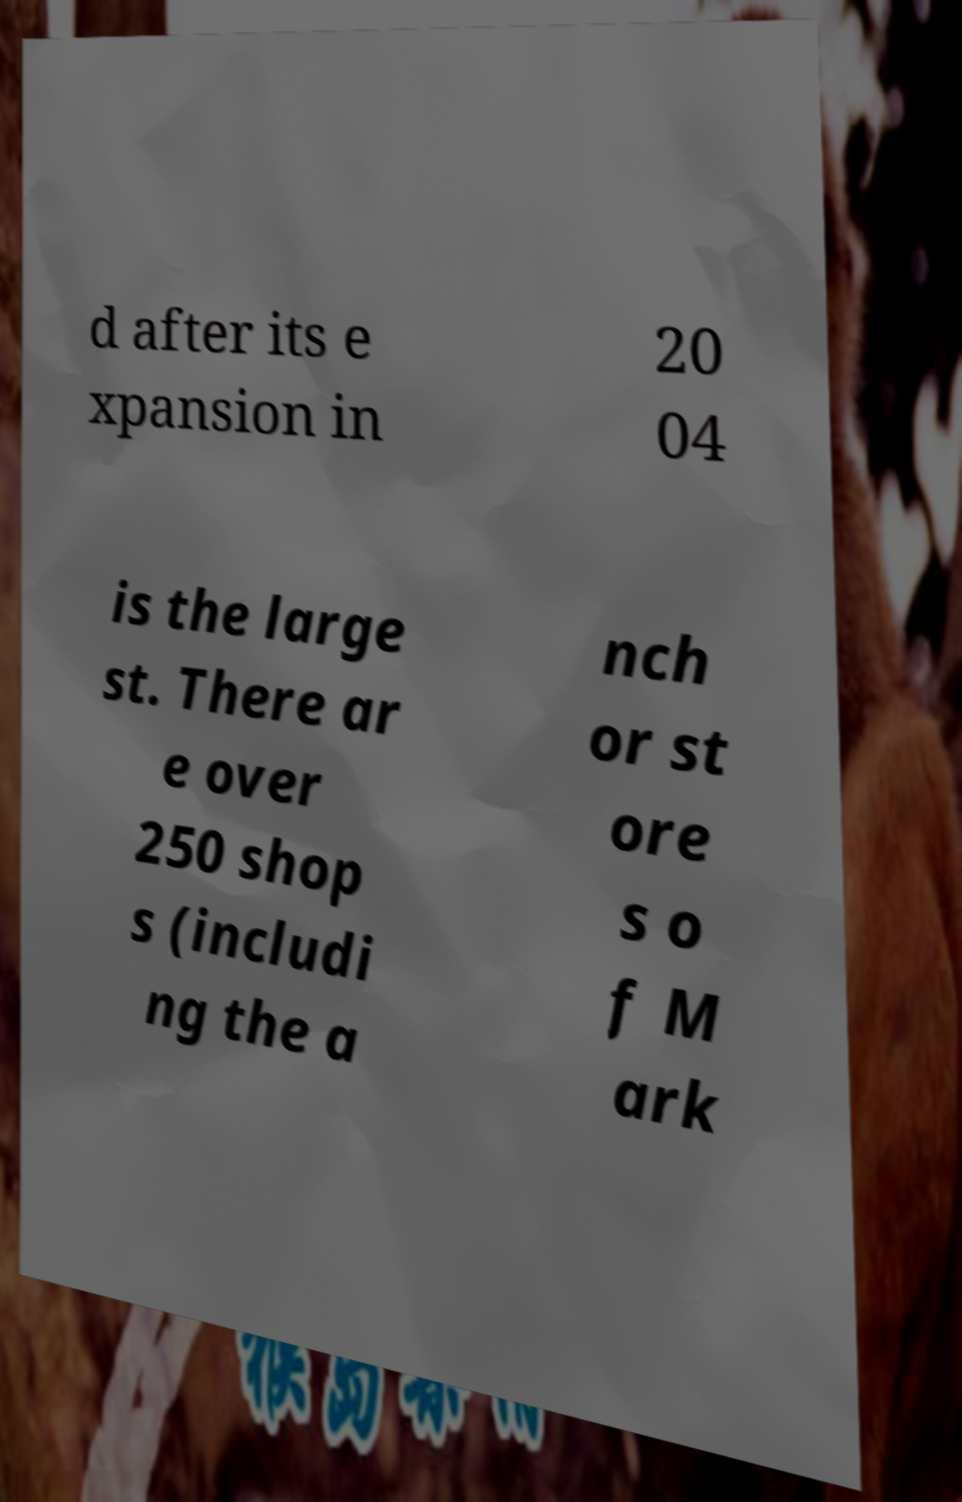Can you accurately transcribe the text from the provided image for me? d after its e xpansion in 20 04 is the large st. There ar e over 250 shop s (includi ng the a nch or st ore s o f M ark 